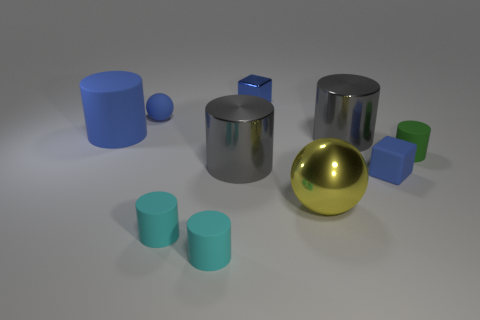Subtract all green rubber cylinders. How many cylinders are left? 5 Subtract all green cylinders. How many cylinders are left? 5 Subtract all cylinders. How many objects are left? 4 Subtract all yellow cylinders. Subtract all cyan cubes. How many cylinders are left? 6 Subtract all yellow spheres. How many blue cylinders are left? 1 Subtract all tiny gray metal spheres. Subtract all small blue matte things. How many objects are left? 8 Add 8 small blue rubber balls. How many small blue rubber balls are left? 9 Add 1 rubber things. How many rubber things exist? 7 Subtract 2 cyan cylinders. How many objects are left? 8 